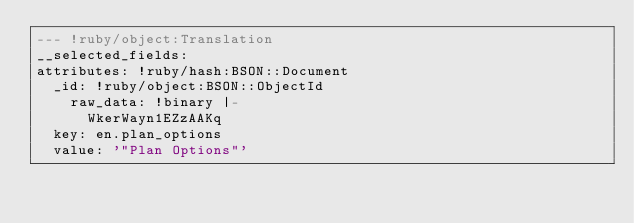<code> <loc_0><loc_0><loc_500><loc_500><_YAML_>--- !ruby/object:Translation
__selected_fields: 
attributes: !ruby/hash:BSON::Document
  _id: !ruby/object:BSON::ObjectId
    raw_data: !binary |-
      WkerWayn1EZzAAKq
  key: en.plan_options
  value: '"Plan Options"'
</code> 